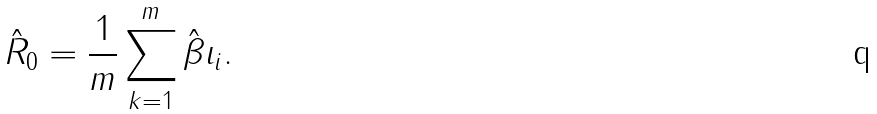Convert formula to latex. <formula><loc_0><loc_0><loc_500><loc_500>\hat { R } _ { 0 } = \frac { 1 } { m } \sum _ { k = 1 } ^ { m } \hat { \beta } \iota _ { i } .</formula> 